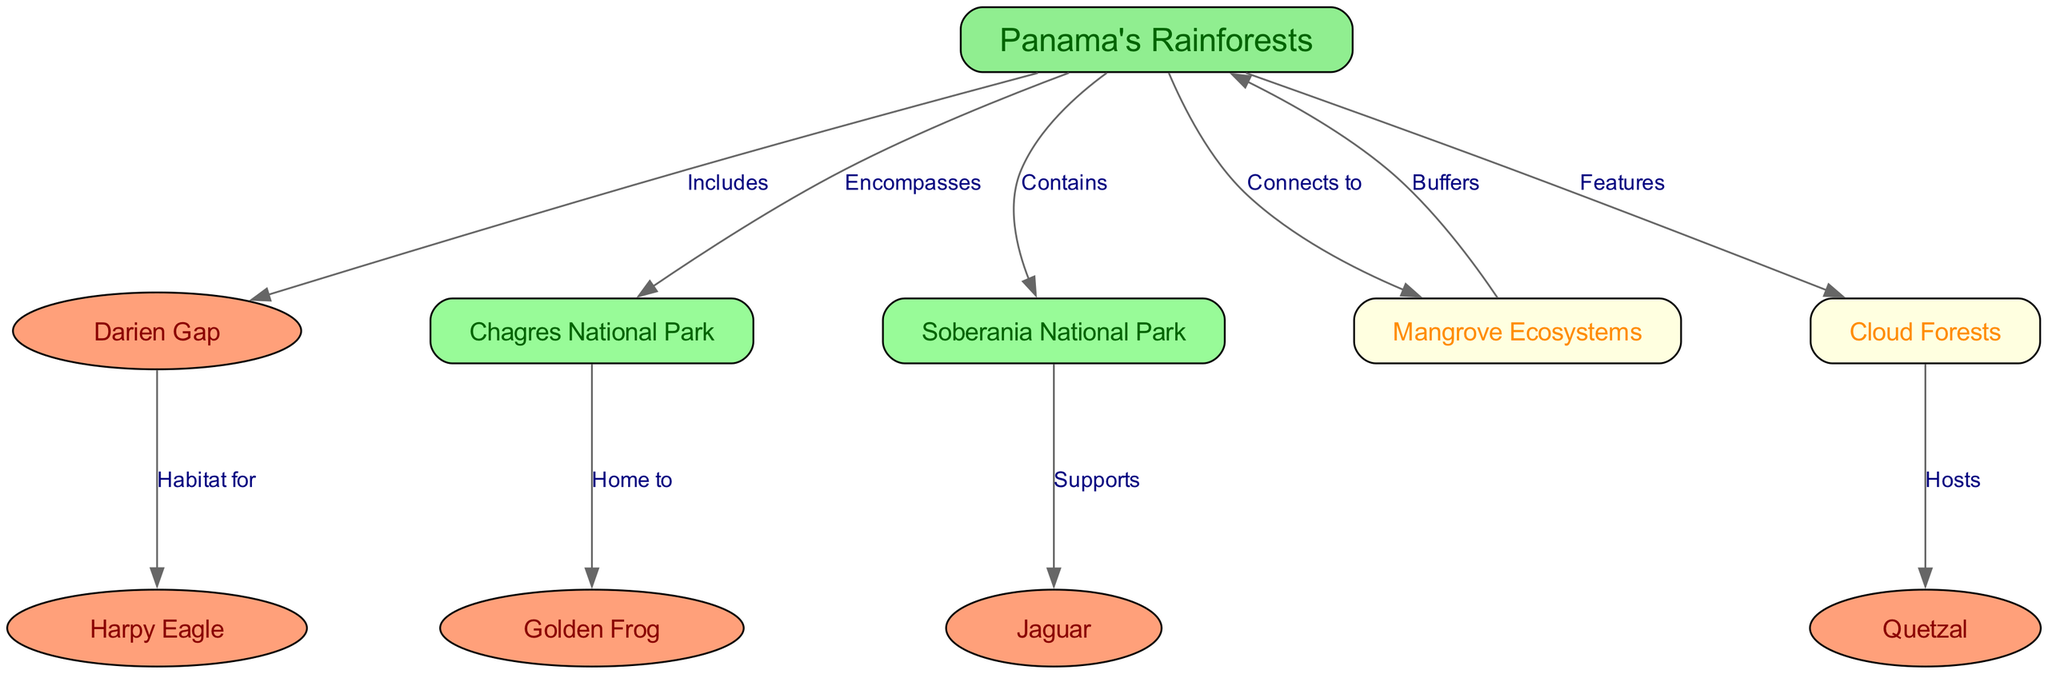What are the three national parks represented in Panama's rainforests? The diagram shows three nodes specifically identifying national parks: Chagres National Park, Soberania National Park, and Darien Gap.
Answer: Chagres National Park, Soberania National Park, Darien Gap Which animal is supported by Soberania National Park? The relationship labeled "Supports" from Soberania National Park points to the Jaguar, indicating that it is a species found and supported in that park.
Answer: Jaguar How many edges connect Panama's rainforests to other nodes? By counting the edges that originate from the node "Panama's Rainforests," which includes connections to five different nodes, we can determine the total number of outgoing edges.
Answer: 5 What type of ecosystems connect to Panama's rainforests? The diagram indicates that "Mangrove Ecosystems" and "Cloud Forests" are types of ecosystems that connect to Panama's rainforests as per the relationships specified in the edges.
Answer: Mangrove Ecosystems, Cloud Forests Which bird species is indicated as a host in Cloud Forests? The diagram has a directed edge from Cloud Forests to Quetzal, labeled "Hosts," indicating that Cloud Forests are known to host this bird species.
Answer: Quetzal What is the habitat for the Harpy Eagle? The edge labeled "Habitat for" indicates that the Harpy Eagle specifically resides within the Darien Gap region, as shown by the connection between these two nodes.
Answer: Darien Gap Which ecosystem buffers Panama's rainforests? The diagram provides an edge that states "Buffers" from Mangrove Ecosystems back to Panama's Rainforests, revealing that Mangrove Ecosystems provide a buffering effect for the rainforests.
Answer: Mangrove Ecosystems How many unique species are mentioned in the diagram? Summing the unique species represented by nodes in the diagram, which are the Harpy Eagle, Golden Frog, Jaguar, and Quetzal, gives us the total number of different species.
Answer: 4 Which specific park encompasses Chagres National Park? Referring to the edge labeled "Encompasses," it points from Panama's Rainforests to Chagres National Park, indicating that Chagres is included within Panama's Rainforests.
Answer: Panama's Rainforests 